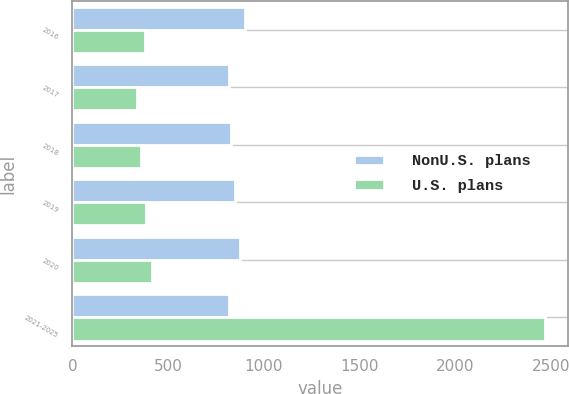Convert chart. <chart><loc_0><loc_0><loc_500><loc_500><stacked_bar_chart><ecel><fcel>2016<fcel>2017<fcel>2018<fcel>2019<fcel>2020<fcel>2021-2025<nl><fcel>NonU.S. plans<fcel>903<fcel>818<fcel>828<fcel>848<fcel>876<fcel>818<nl><fcel>U.S. plans<fcel>377<fcel>337<fcel>359<fcel>382<fcel>415<fcel>2467<nl></chart> 